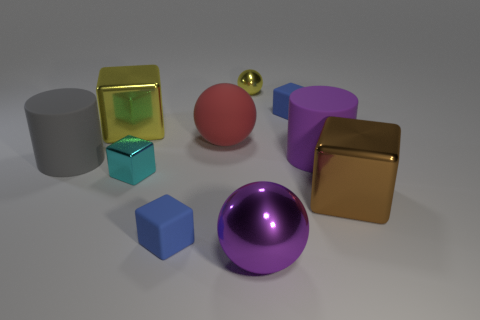How many other objects are the same shape as the brown metal object?
Your response must be concise. 4. Do the big purple matte object and the big gray thing have the same shape?
Give a very brief answer. Yes. What number of objects are either tiny blue rubber cubes in front of the large gray cylinder or yellow objects behind the yellow shiny block?
Offer a terse response. 2. How many things are either matte cubes or large yellow matte blocks?
Your response must be concise. 2. There is a brown shiny object that is in front of the purple matte cylinder; what number of objects are in front of it?
Give a very brief answer. 2. How many other things are the same size as the red object?
Make the answer very short. 5. Does the red matte thing that is on the left side of the large brown metallic cube have the same shape as the tiny yellow object?
Make the answer very short. Yes. What is the big sphere that is behind the large brown cube made of?
Offer a terse response. Rubber. The object that is the same color as the small sphere is what shape?
Make the answer very short. Cube. Are there any tiny yellow objects that have the same material as the brown object?
Provide a short and direct response. Yes. 